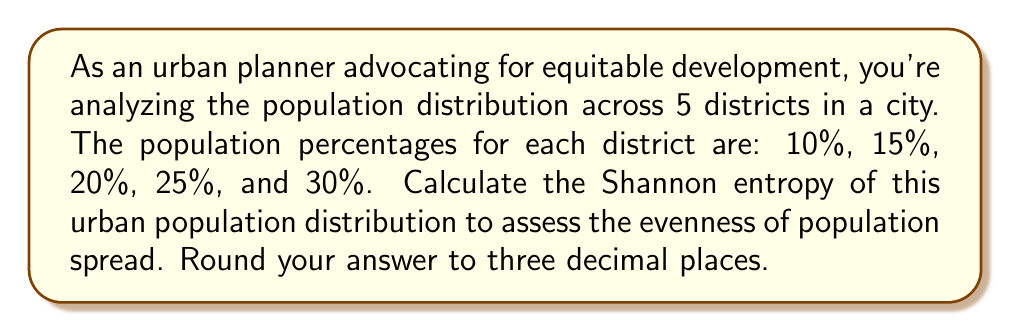What is the answer to this math problem? To calculate the Shannon entropy of the urban population distribution, we'll use the formula:

$$H = -\sum_{i=1}^{n} p_i \log_2(p_i)$$

Where:
- $H$ is the Shannon entropy
- $p_i$ is the probability (in this case, the population percentage) of each district
- $n$ is the number of districts

Step 1: Convert percentages to decimals
- District 1: 10% = 0.10
- District 2: 15% = 0.15
- District 3: 20% = 0.20
- District 4: 25% = 0.25
- District 5: 30% = 0.30

Step 2: Calculate each term of the sum
1. $-0.10 \log_2(0.10) = 0.332193$
2. $-0.15 \log_2(0.15) = 0.410351$
3. $-0.20 \log_2(0.20) = 0.464386$
4. $-0.25 \log_2(0.25) = 0.500000$
5. $-0.30 \log_2(0.30) = 0.521061$

Step 3: Sum all terms
$$H = 0.332193 + 0.410351 + 0.464386 + 0.500000 + 0.521061 = 2.227991$$

Step 4: Round to three decimal places
$$H \approx 2.228$$

This entropy value indicates the degree of evenness in the population distribution. A higher value suggests a more even distribution, while a lower value indicates a more concentrated population. The maximum entropy for 5 districts would be $\log_2(5) \approx 2.322$, which occurs when the population is evenly distributed (20% in each district).
Answer: 2.228 